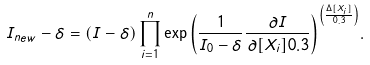Convert formula to latex. <formula><loc_0><loc_0><loc_500><loc_500>I _ { n e w } - \delta = ( I - \delta ) \prod _ { i = 1 } ^ { n } { \exp \left ( \frac { 1 } { I _ { 0 } - \delta } \frac { \partial { I } } { \partial { [ X _ { i } ] } 0 . 3 } \right ) } ^ { \left ( \frac { \Delta { [ X _ { i } ] } } { 0 . 3 } \right ) } .</formula> 